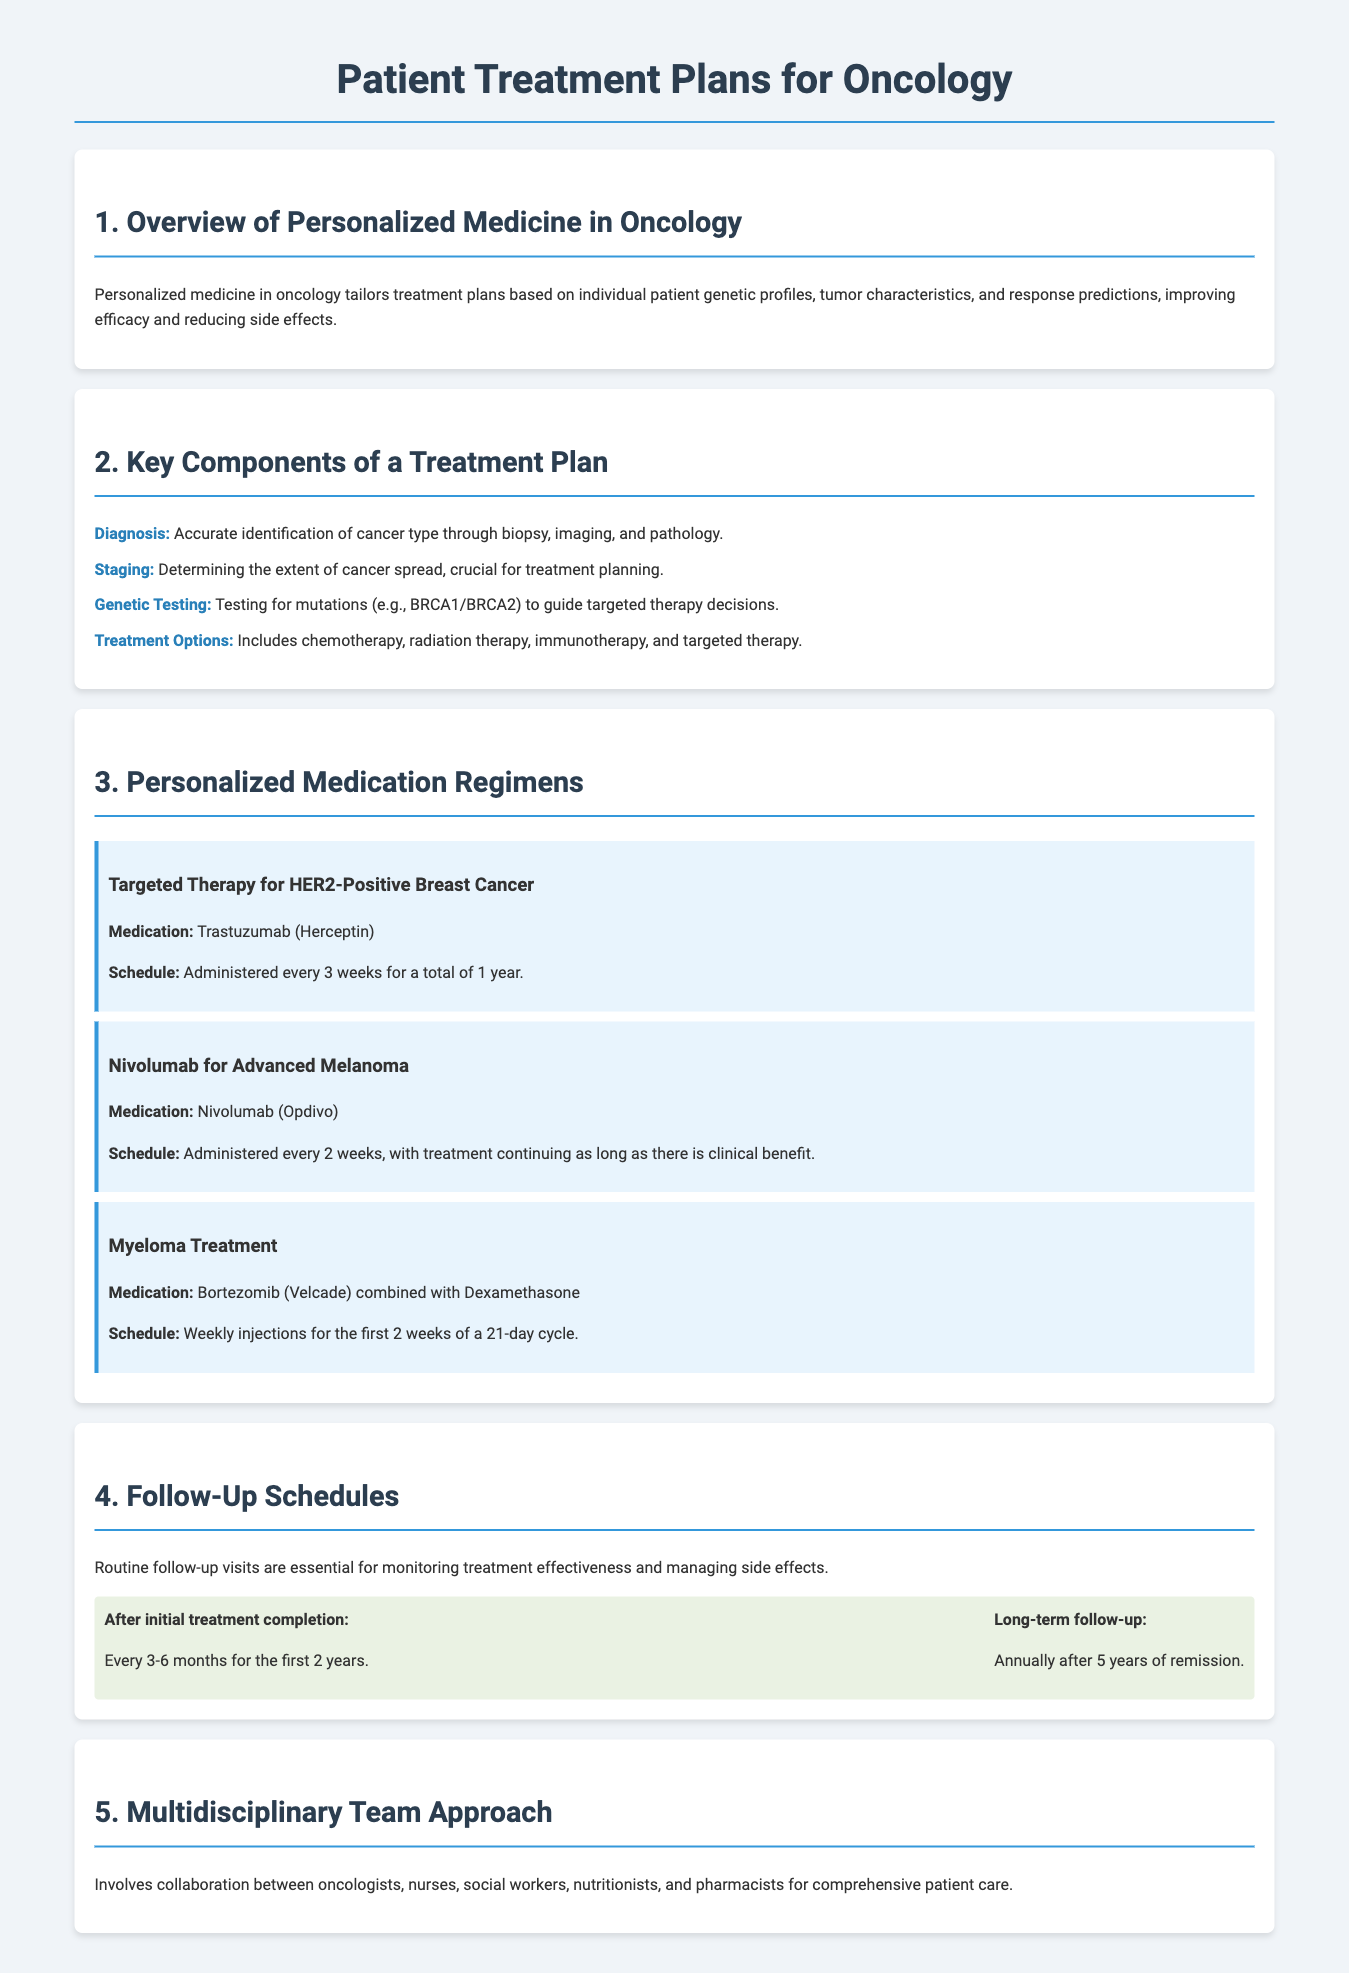What is personalized medicine in oncology? Personalized medicine tailors treatment plans based on individual patient genetic profiles, tumor characteristics, and response predictions.
Answer: Personalized medicine What is the schedule for Trastuzumab treatment? The schedule is administered every 3 weeks for a total of 1 year.
Answer: Every 3 weeks for a total of 1 year What cancer type is targeted by Nivolumab? Nivolumab is used for Advanced Melanoma.
Answer: Advanced Melanoma How often should follow-up visits occur after initial treatment completion? Follow-up visits should occur every 3-6 months for the first 2 years.
Answer: Every 3-6 months for the first 2 years What is the medication used for Myeloma treatment? The medication is Bortezomib combined with Dexamethasone.
Answer: Bortezomib (Velcade) combined with Dexamethasone What is the long-term follow-up schedule after 5 years of remission? The long-term follow-up is annually after 5 years of remission.
Answer: Annually after 5 years of remission Which professionals are involved in the multidisciplinary team approach? The team includes oncologists, nurses, social workers, nutritionists, and pharmacists.
Answer: Oncologists, nurses, social workers, nutritionists, and pharmacists 